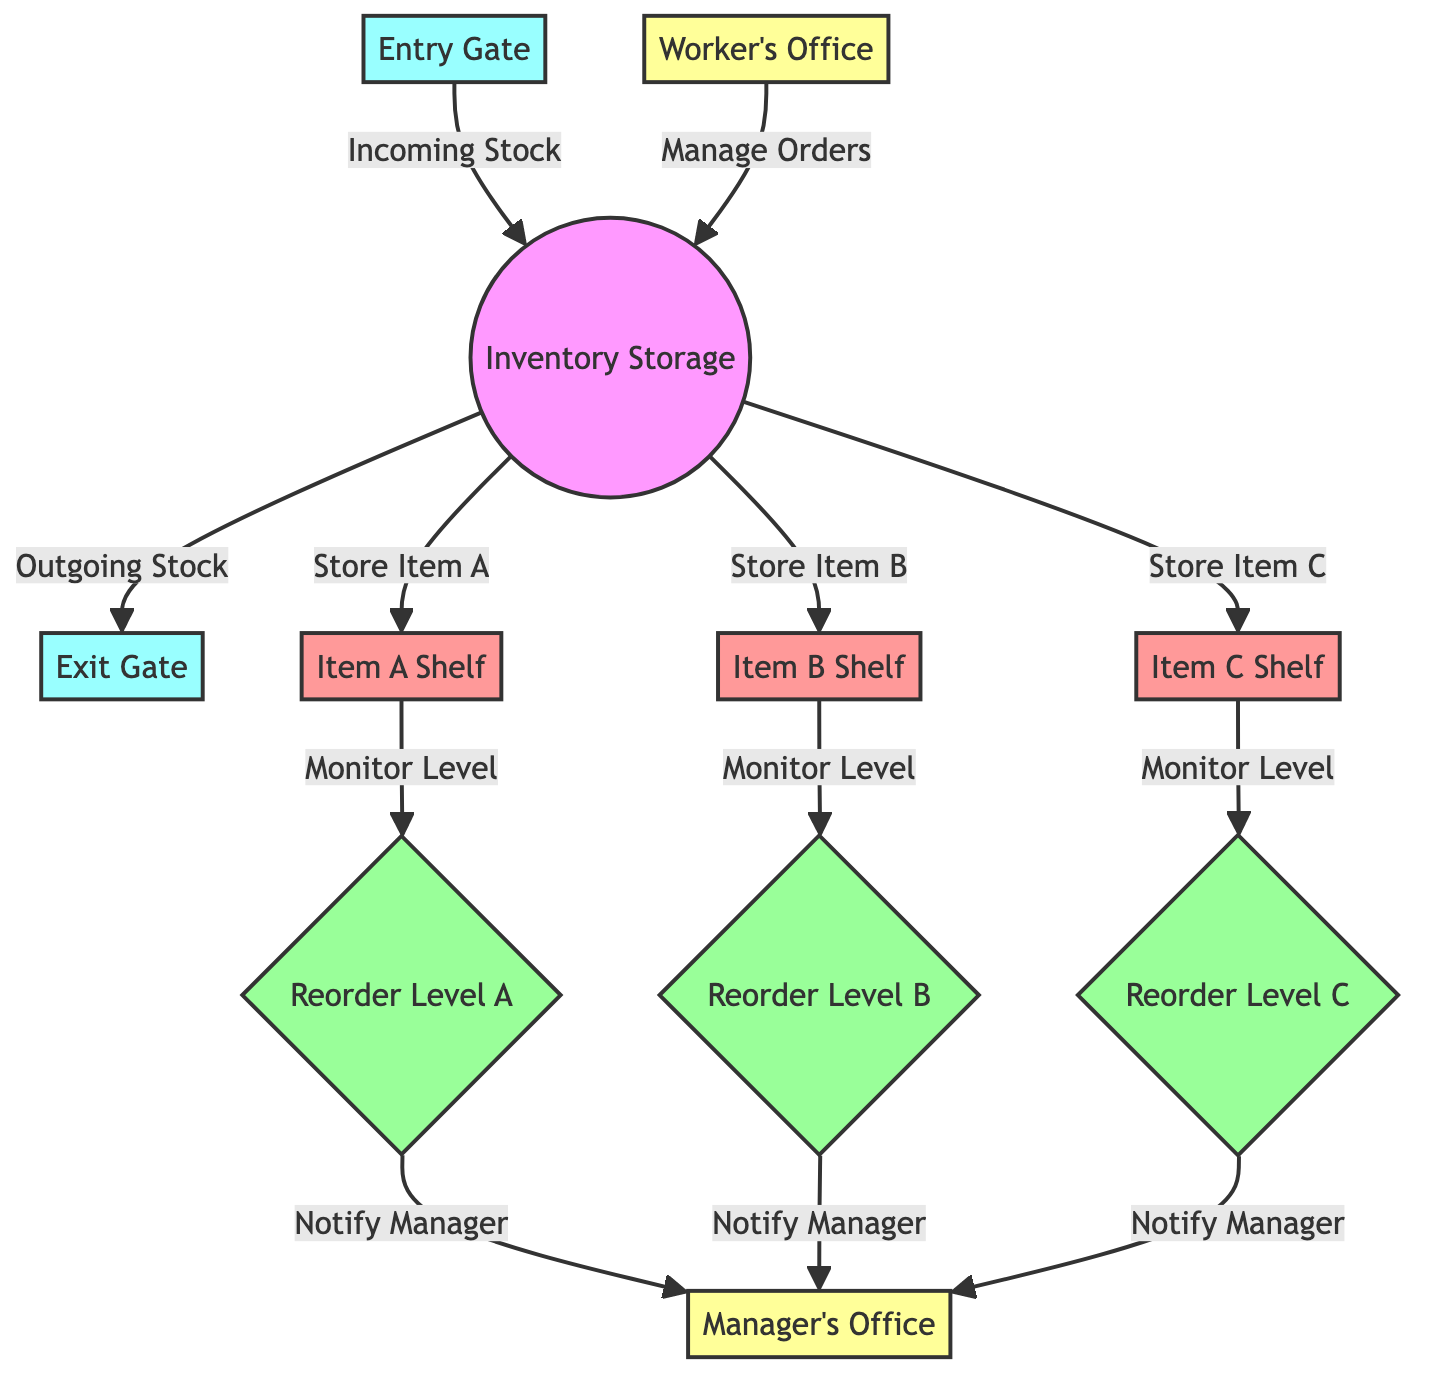What is the role of the entry gate in the diagram? The entry gate serves as the point where incoming stock enters the inventory storage. It connects directly to the inventory node, indicating that stock is brought in through this gate.
Answer: Incoming Stock How many reorder levels are shown in the diagram? The diagram displays three reorder levels, one for each item shelf (Item A, Item B, and Item C), indicating specific points at which replenishment is needed.
Answer: 3 Which office manages orders according to the diagram? The worker's office is responsible for managing orders, as indicated by an arrow directing from the worker's office to the inventory node.
Answer: Worker’s Office What is the function of the reorder levels in this diagram? The reorder levels monitor the inventory levels of items on their respective shelves, and when they reach a certain point, they notify the manager's office for further action such as restocking.
Answer: Monitor Inventory How does the outgoing stock leave the inventory? The outgoing stock exits through the exit gate, as indicated by the pathway from the inventory node to the exit gate in the diagram.
Answer: Exit Gate Which items are stored in the inventory? The items stored in the inventory are Item A, Item B, and Item C, as indicated by the connections from the inventory node to each respective item shelf.
Answer: Item A, Item B, Item C How is the manager notified about reorder levels? The reorder levels for each item shelf are connected to the manager's office, implying that when an item's reorder level is reached, a notification is sent to the manager's office.
Answer: Notify Manager What types of shelves are illustrated in the inventory layout? The inventory layout includes three types of shelves, specifically designated for Item A, Item B, and Item C, each represented by distinct shelf nodes.
Answer: Item A Shelf, Item B Shelf, Item C Shelf Which two gates are depicted in the diagram? The diagram includes two gates: the entry gate, where stock comes in, and the exit gate, where stock goes out. Both gates are essential for managing inventory flow.
Answer: Entry Gate, Exit Gate 